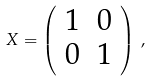<formula> <loc_0><loc_0><loc_500><loc_500>X = \left ( \begin{array} { r r } 1 & 0 \\ 0 & 1 \end{array} \right ) \, ,</formula> 